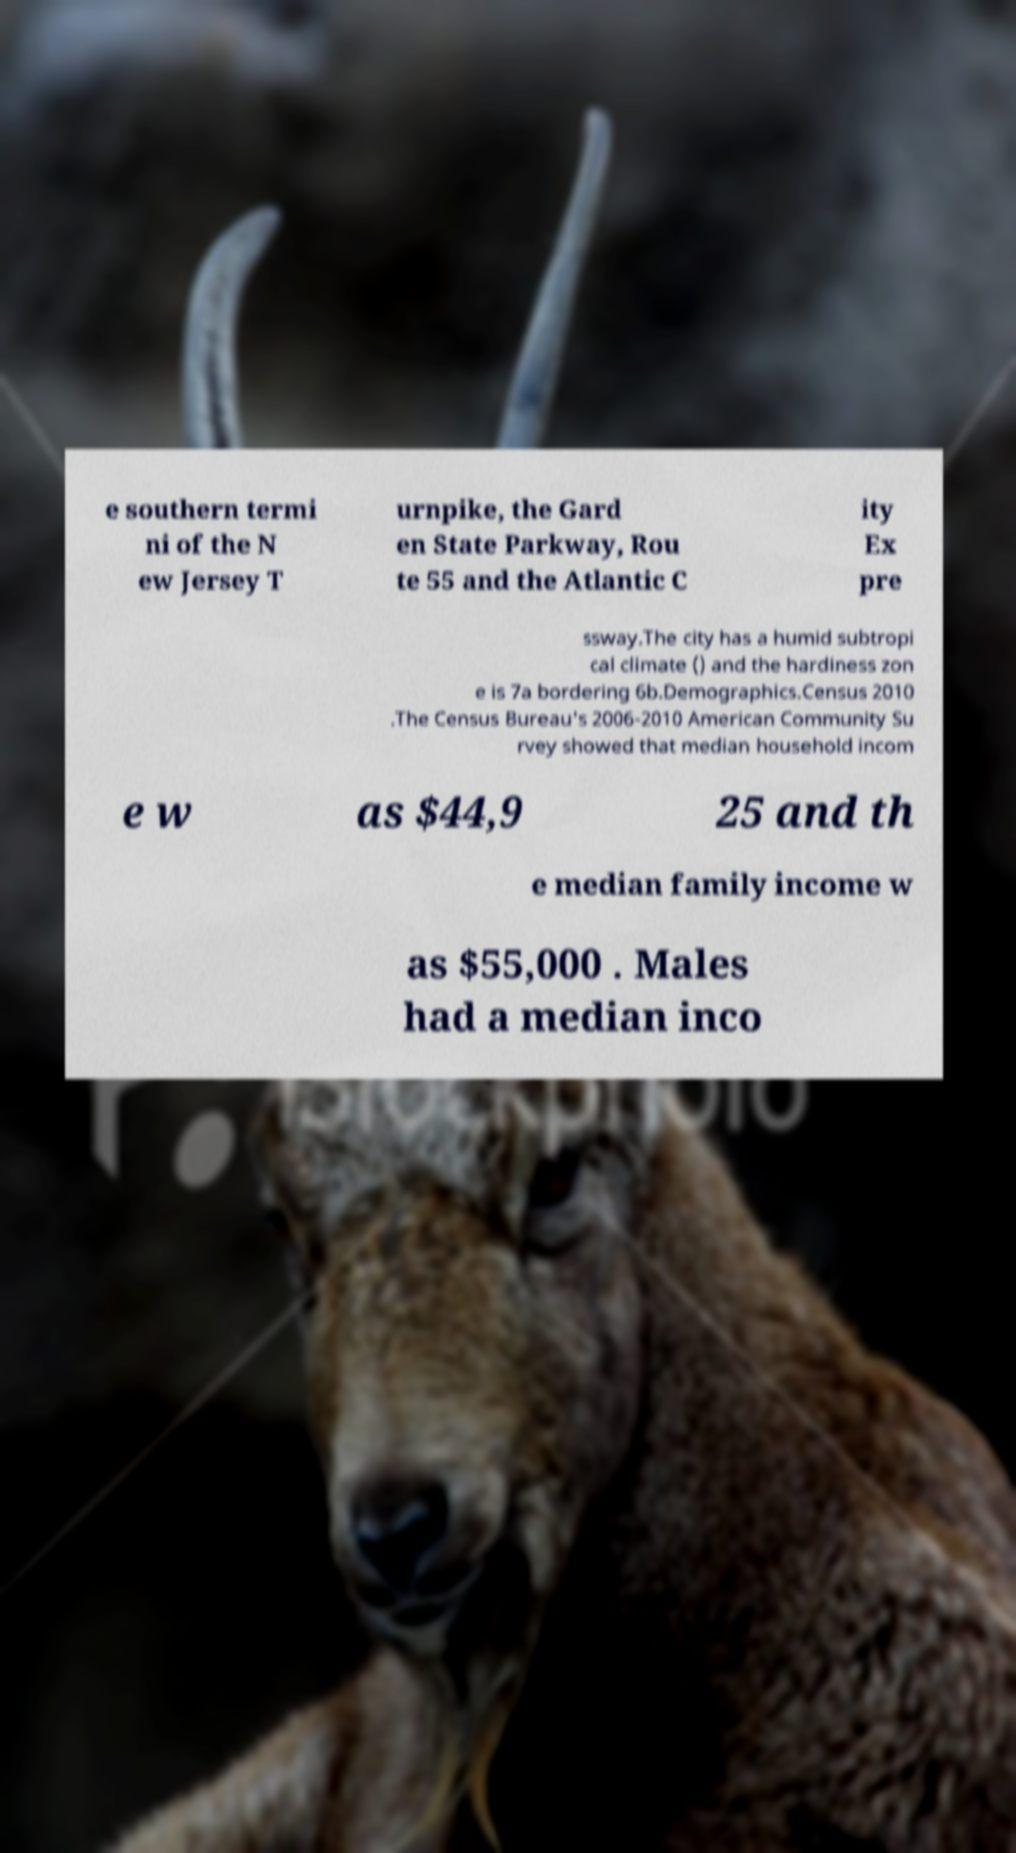Could you assist in decoding the text presented in this image and type it out clearly? e southern termi ni of the N ew Jersey T urnpike, the Gard en State Parkway, Rou te 55 and the Atlantic C ity Ex pre ssway.The city has a humid subtropi cal climate () and the hardiness zon e is 7a bordering 6b.Demographics.Census 2010 .The Census Bureau's 2006-2010 American Community Su rvey showed that median household incom e w as $44,9 25 and th e median family income w as $55,000 . Males had a median inco 